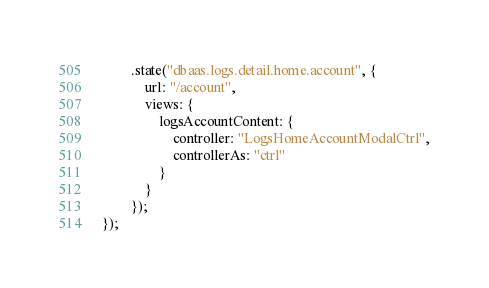Convert code to text. <code><loc_0><loc_0><loc_500><loc_500><_JavaScript_>        .state("dbaas.logs.detail.home.account", {
            url: "/account",
            views: {
                logsAccountContent: {
                    controller: "LogsHomeAccountModalCtrl",
                    controllerAs: "ctrl"
                }
            }
        });
});
</code> 